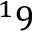<formula> <loc_0><loc_0><loc_500><loc_500>^ { 1 } 9</formula> 